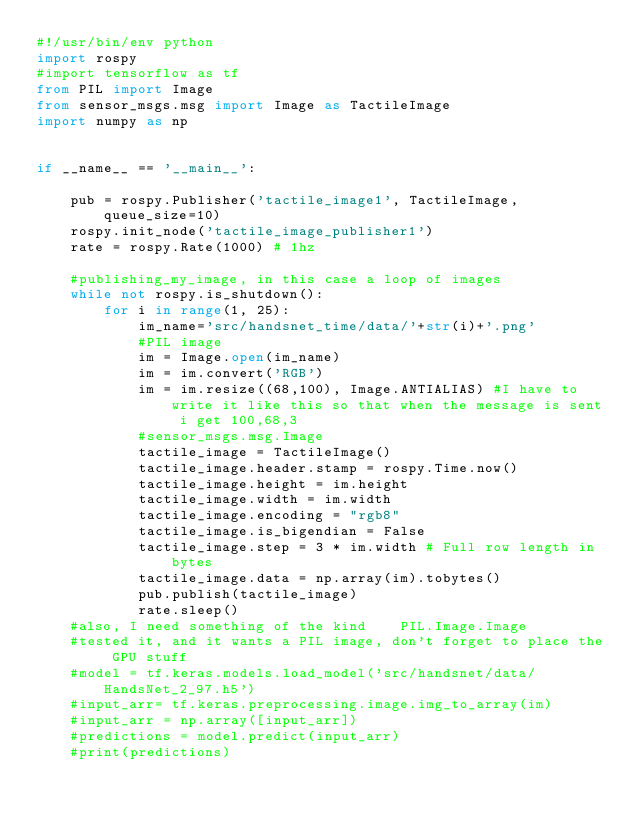Convert code to text. <code><loc_0><loc_0><loc_500><loc_500><_Python_>#!/usr/bin/env python
import rospy
#import tensorflow as tf
from PIL import Image
from sensor_msgs.msg import Image as TactileImage
import numpy as np


if __name__ == '__main__':

    pub = rospy.Publisher('tactile_image1', TactileImage, queue_size=10)
    rospy.init_node('tactile_image_publisher1')
    rate = rospy.Rate(1000) # 1hz

    #publishing_my_image, in this case a loop of images
    while not rospy.is_shutdown():
        for i in range(1, 25):
            im_name='src/handsnet_time/data/'+str(i)+'.png'
            #PIL image
            im = Image.open(im_name)
            im = im.convert('RGB')
            im = im.resize((68,100), Image.ANTIALIAS) #I have to write it like this so that when the message is sent i get 100,68,3
            #sensor_msgs.msg.Image
            tactile_image = TactileImage()
            tactile_image.header.stamp = rospy.Time.now()
            tactile_image.height = im.height
            tactile_image.width = im.width
            tactile_image.encoding = "rgb8"
            tactile_image.is_bigendian = False
            tactile_image.step = 3 * im.width # Full row length in bytes
            tactile_image.data = np.array(im).tobytes()
            pub.publish(tactile_image)
            rate.sleep()
    #also, I need something of the kind    PIL.Image.Image
    #tested it, and it wants a PIL image, don't forget to place the GPU stuff
    #model = tf.keras.models.load_model('src/handsnet/data/HandsNet_2_97.h5')
    #input_arr= tf.keras.preprocessing.image.img_to_array(im)
    #input_arr = np.array([input_arr])  
    #predictions = model.predict(input_arr)
    #print(predictions)



</code> 